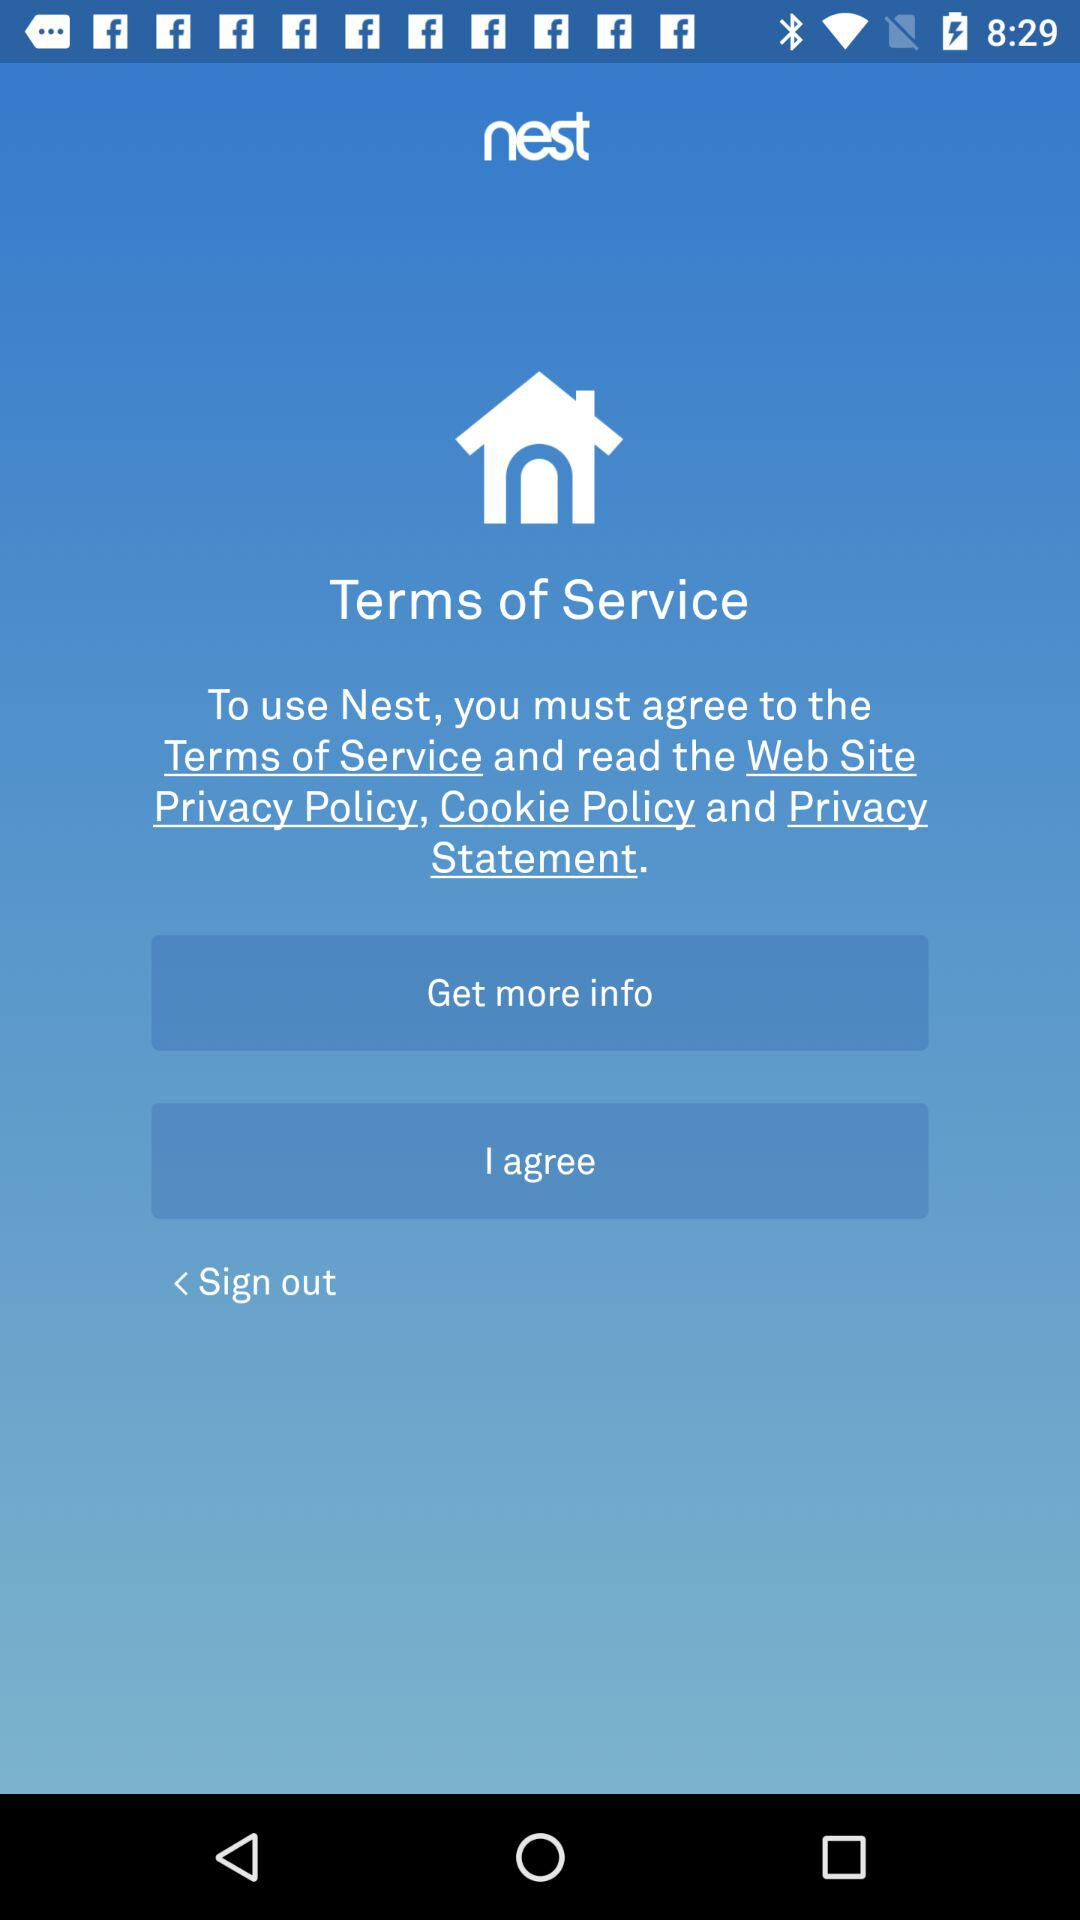What is the app name? The app name is "nest". 